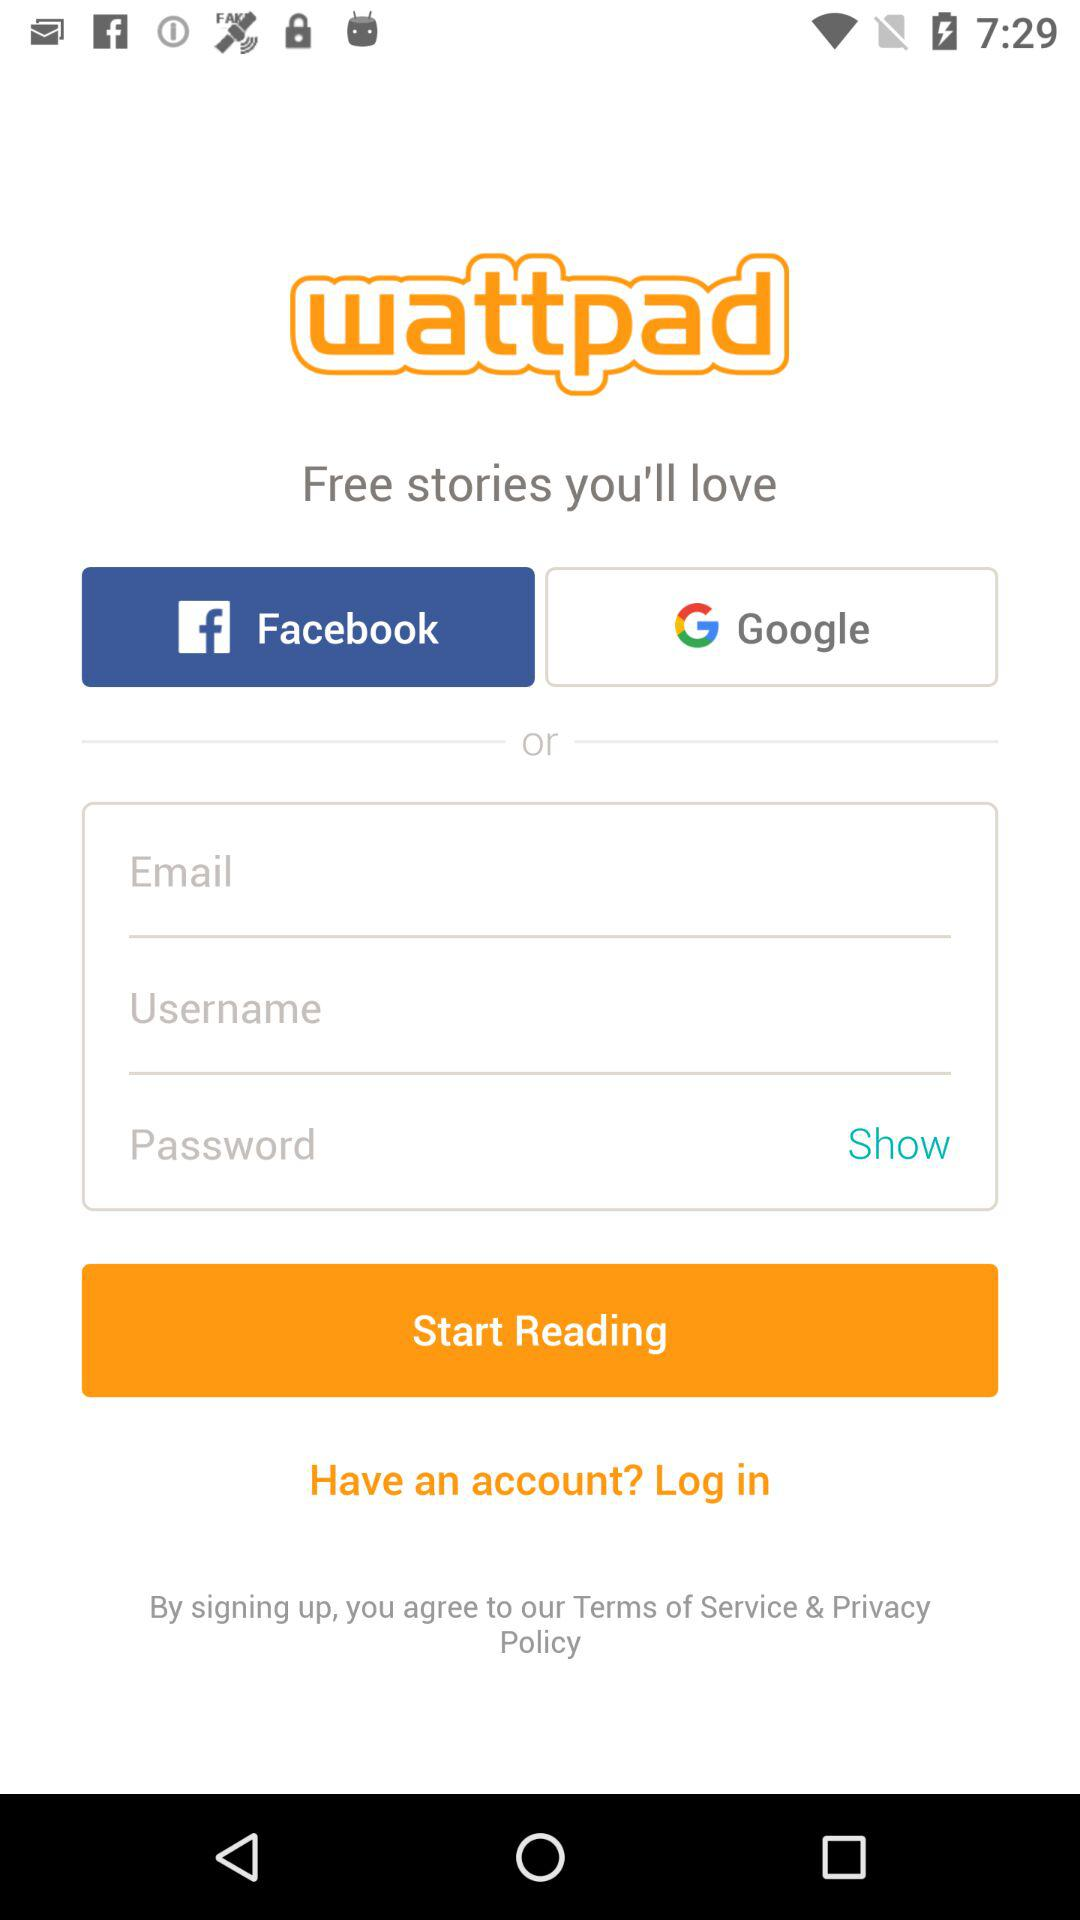What applications can we use to log in? You can log in with "Facebook" and "Google". 